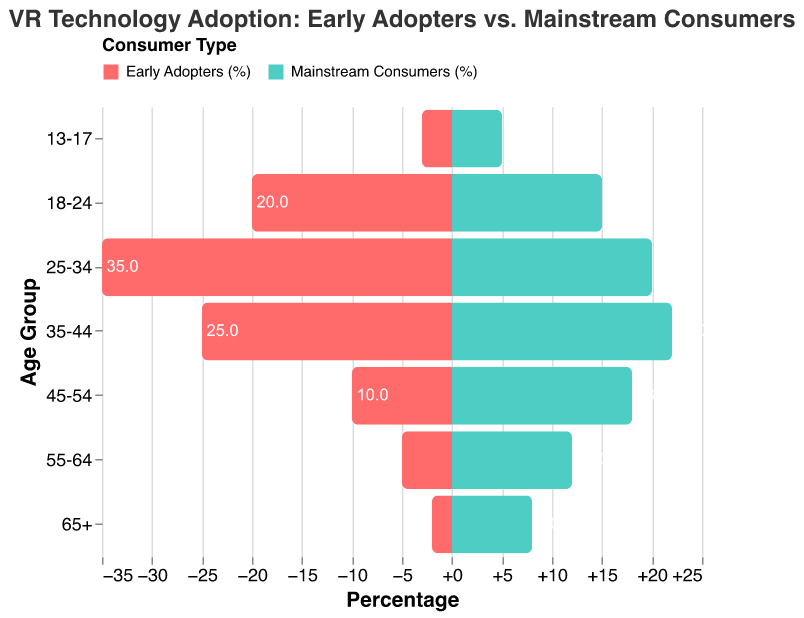What is the title of the plot? The title of the plot can be found at the top center and it reads "VR Technology Adoption: Early Adopters vs. Mainstream Consumers".
Answer: VR Technology Adoption: Early Adopters vs. Mainstream Consumers Which age group has the highest percentage of early adopters? The highest bar in the "Early Adopters (%)" category is for the age group "25-34", indicating they have the highest percentage.
Answer: 25-34 How does the percentage of mainstream consumers aged 65+ compare to early adopters of the same age group? By examining the "65+" age group, the length of the green bar (Mainstream Consumers) is longer than the red bar (Early Adopters). Mainstream Consumers have a higher percentage which is 8% compared to Early Adopters' 2%.
Answer: Mainstream consumers aged 65+ have a higher percentage than early adopters What is the total percentage of early adopters across all age groups? To find the total percentage, sum up the percentages of early adopters across all age groups: 2 + 5 + 10 + 25 + 35 + 20 + 3 = 100.
Answer: 100% Which age group shows the largest difference in percentage between early adopters and mainstream consumers? By calculating the difference for each age group and comparing them, the age group "25-34" has the largest difference: 35% (Early Adopters) - 20% (Mainstream Consumers) = 15%.
Answer: 25-34 What is the median age group for mainstream consumers? To find the median, list the percentages for mainstream consumers in ascending order: 5, 8, 12, 15, 18, 20, 22. The median value is the one in the middle, which is for the age group "18-24".
Answer: 18-24 Compare the percentages for age group 35-44 between early adopters and mainstream consumers. For the age group 35-44, the percentage for early adopters is 25%, while for mainstream consumers it is 22%.
Answer: 25% (early adopters), 22% (mainstream consumers) Which age group has an equal percentage of early adopters and mainstream consumers? Scanning through the age groups, we see that no two percentages match between early adopters and mainstream consumers.
Answer: None What is the average percentage of mainstream consumers across all age groups? Sum the percentages for mainstream consumers and divide by the number of age groups: (8 + 12 + 18 + 22 + 20 + 15 + 5) / 7 ≈ 14.29%.
Answer: ~14.29% In which age group is the difference between early adopters and mainstream consumers the smallest? Calculate the differences for each group: 65+ (6%), 55-64 (7%), 45-54 (8%), 35-44 (3%), 25-34 (15%), 18-24 (5%), 13-17 (2%). The smallest difference is for the age group "13-17" (2%).
Answer: 13-17 